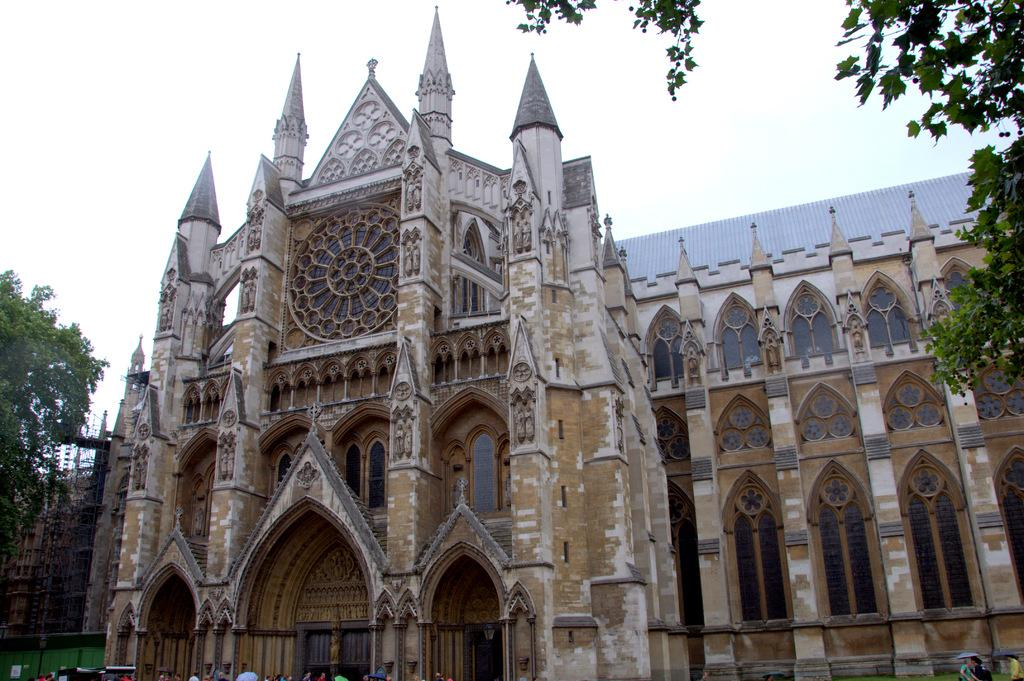What type of structure is present in the image? There is a building in the image. What feature can be seen on the building? The building has windows. What else is visible in the image besides the building? There are trees and people in the image. What is the color of the sky in the image? The sky is white in color. What type of base is used for the voyage in the image? There is no voyage or base present in the image; it features a building, trees, people, and a white sky. Can you hear the people laughing in the image? The image is silent, so we cannot hear any laughter. 